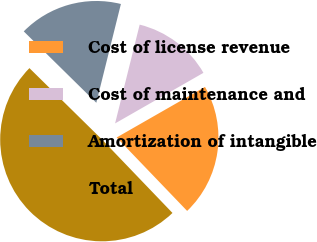Convert chart. <chart><loc_0><loc_0><loc_500><loc_500><pie_chart><fcel>Cost of license revenue<fcel>Cost of maintenance and<fcel>Amortization of intangible<fcel>Total<nl><fcel>21.1%<fcel>12.84%<fcel>16.51%<fcel>49.54%<nl></chart> 